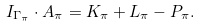<formula> <loc_0><loc_0><loc_500><loc_500>I _ { \Gamma _ { \pi } } \cdot A _ { \pi } = K _ { \pi } + L _ { \pi } - P _ { \pi } .</formula> 